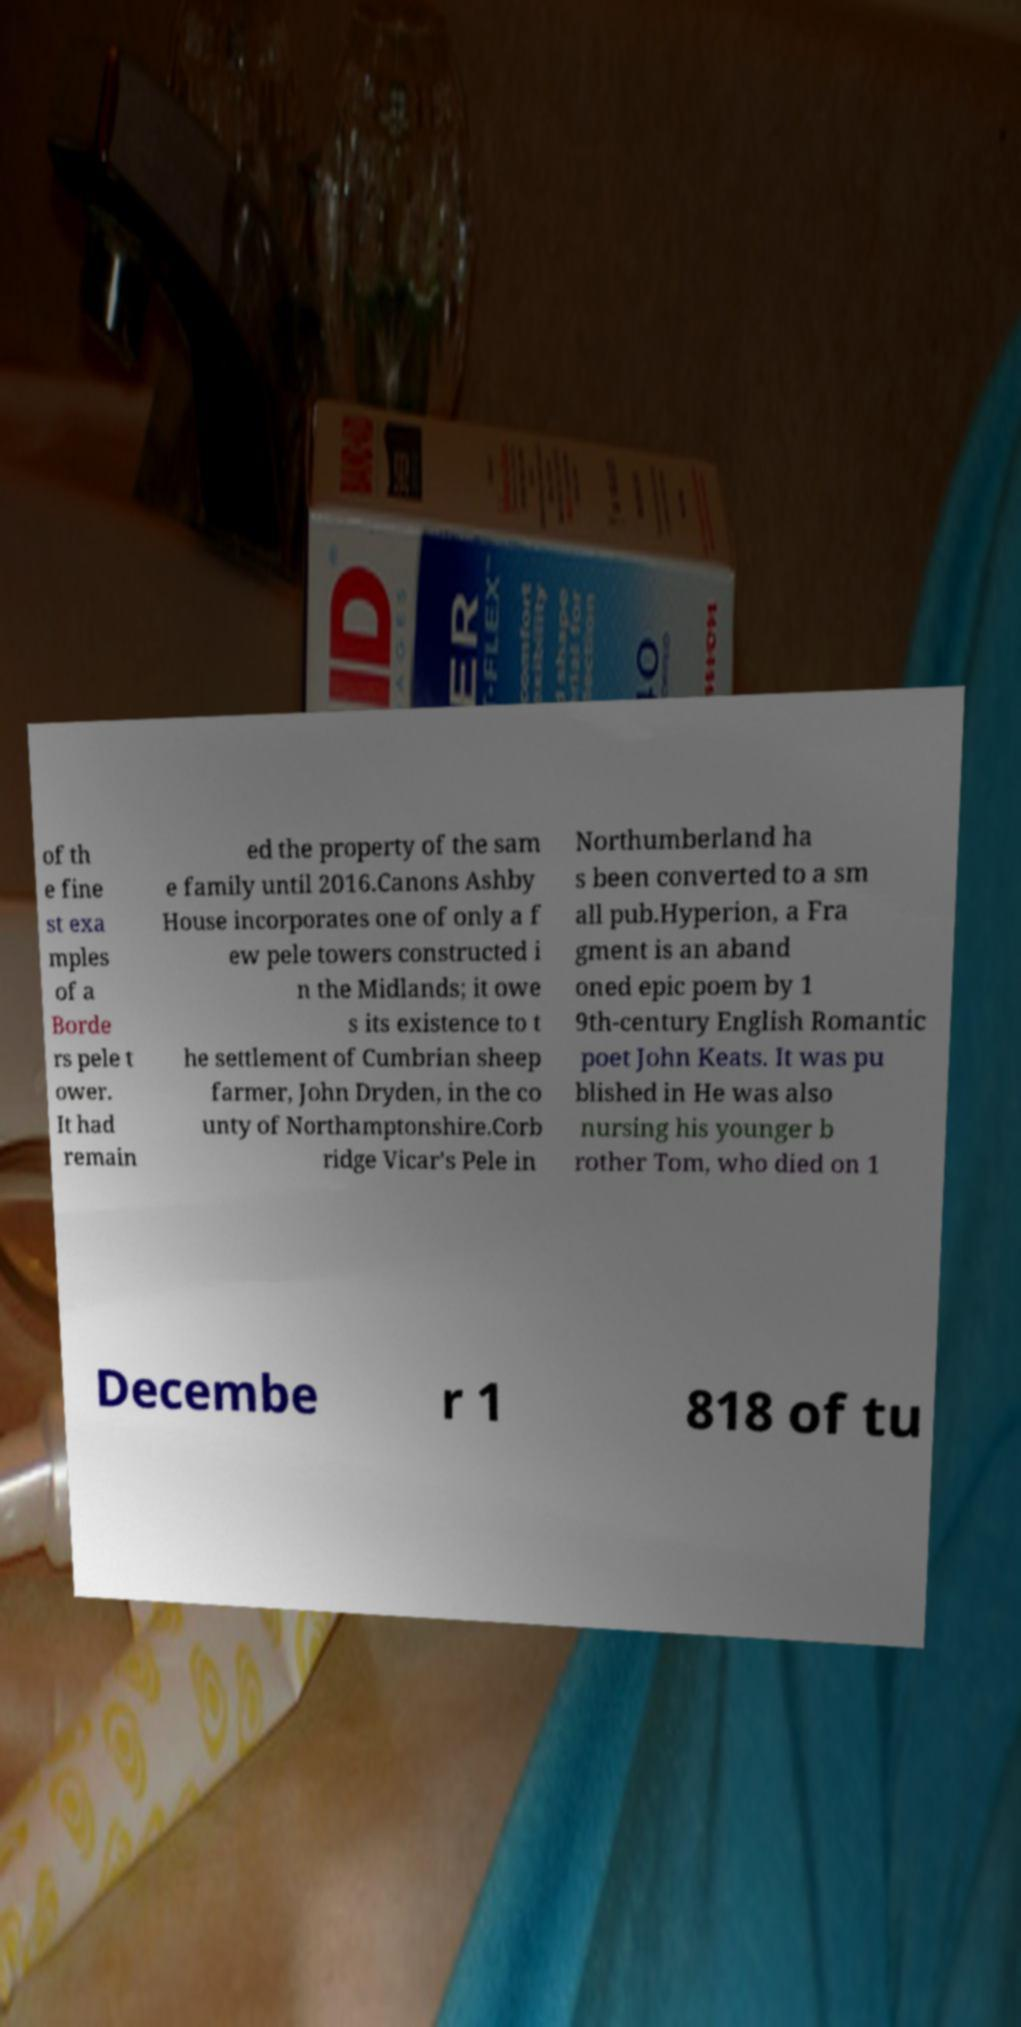There's text embedded in this image that I need extracted. Can you transcribe it verbatim? of th e fine st exa mples of a Borde rs pele t ower. It had remain ed the property of the sam e family until 2016.Canons Ashby House incorporates one of only a f ew pele towers constructed i n the Midlands; it owe s its existence to t he settlement of Cumbrian sheep farmer, John Dryden, in the co unty of Northamptonshire.Corb ridge Vicar's Pele in Northumberland ha s been converted to a sm all pub.Hyperion, a Fra gment is an aband oned epic poem by 1 9th-century English Romantic poet John Keats. It was pu blished in He was also nursing his younger b rother Tom, who died on 1 Decembe r 1 818 of tu 